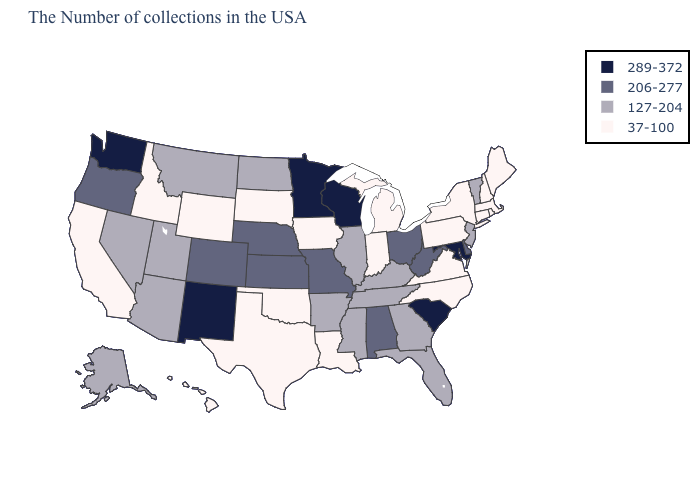Does Iowa have the lowest value in the USA?
Be succinct. Yes. What is the value of Rhode Island?
Write a very short answer. 37-100. Is the legend a continuous bar?
Write a very short answer. No. What is the highest value in the MidWest ?
Write a very short answer. 289-372. Among the states that border California , does Oregon have the lowest value?
Give a very brief answer. No. Does New Mexico have the highest value in the USA?
Short answer required. Yes. Which states have the lowest value in the USA?
Be succinct. Maine, Massachusetts, Rhode Island, New Hampshire, Connecticut, New York, Pennsylvania, Virginia, North Carolina, Michigan, Indiana, Louisiana, Iowa, Oklahoma, Texas, South Dakota, Wyoming, Idaho, California, Hawaii. What is the value of Arizona?
Concise answer only. 127-204. What is the lowest value in the USA?
Write a very short answer. 37-100. Which states have the lowest value in the USA?
Short answer required. Maine, Massachusetts, Rhode Island, New Hampshire, Connecticut, New York, Pennsylvania, Virginia, North Carolina, Michigan, Indiana, Louisiana, Iowa, Oklahoma, Texas, South Dakota, Wyoming, Idaho, California, Hawaii. What is the highest value in states that border Florida?
Keep it brief. 206-277. Name the states that have a value in the range 289-372?
Keep it brief. Maryland, South Carolina, Wisconsin, Minnesota, New Mexico, Washington. What is the lowest value in the USA?
Be succinct. 37-100. Among the states that border Colorado , does Arizona have the lowest value?
Quick response, please. No. Name the states that have a value in the range 127-204?
Give a very brief answer. Vermont, New Jersey, Florida, Georgia, Kentucky, Tennessee, Illinois, Mississippi, Arkansas, North Dakota, Utah, Montana, Arizona, Nevada, Alaska. 